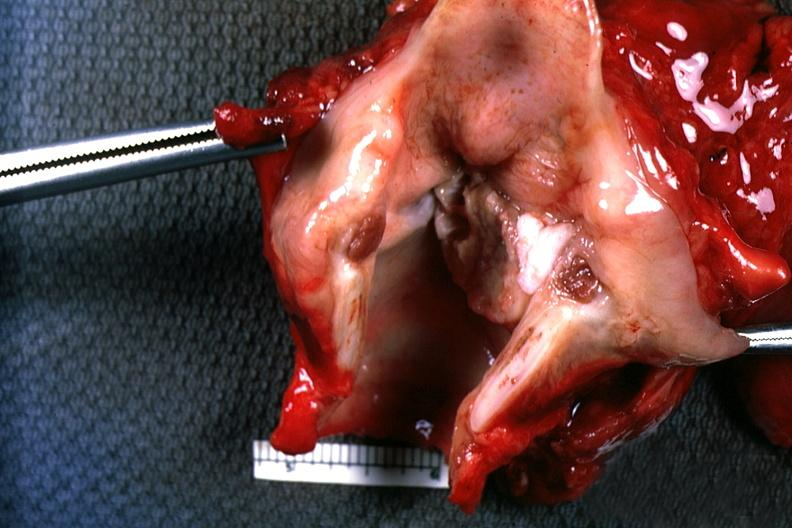what does this image show?
Answer the question using a single word or phrase. Excellent depiction natural color large ulcerative carcinoma on left cord 